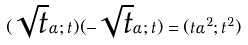<formula> <loc_0><loc_0><loc_500><loc_500>( \sqrt { t } \alpha ; t ) ( - \sqrt { t } \alpha ; t ) = ( t \alpha ^ { 2 } ; t ^ { 2 } )</formula> 